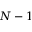Convert formula to latex. <formula><loc_0><loc_0><loc_500><loc_500>N - 1</formula> 